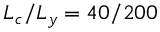Convert formula to latex. <formula><loc_0><loc_0><loc_500><loc_500>L _ { c } / L _ { y } = 4 0 / 2 0 0</formula> 